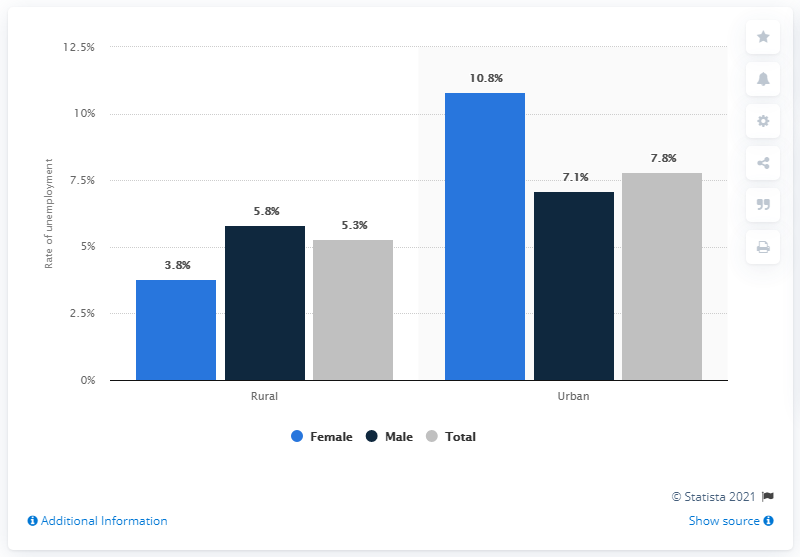Give some essential details in this illustration. The difference between the total rate of unemployment between rural and urban India in 2017-18 was 2.5%. Female literacy has the lowest rate of unemployment in rural and urban India as of 2017-18, according to the latest available data. 